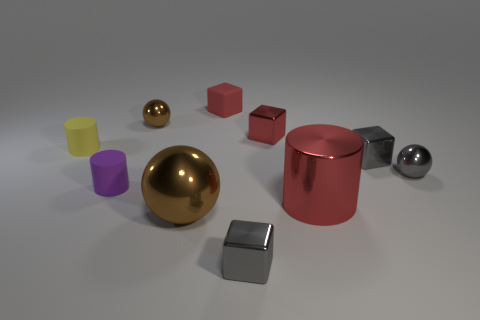What number of small objects are either gray metallic things or matte things?
Keep it short and to the point. 6. Is there anything else that is the same color as the metal cylinder?
Your response must be concise. Yes. There is a big brown object that is the same material as the small brown object; what shape is it?
Provide a short and direct response. Sphere. What size is the metallic thing that is in front of the large brown object?
Your response must be concise. Small. What shape is the large red thing?
Keep it short and to the point. Cylinder. There is a gray metallic thing that is to the left of the large cylinder; is its size the same as the brown shiny object that is behind the small yellow object?
Offer a terse response. Yes. How big is the gray metal cube that is on the right side of the gray metal cube that is in front of the cylinder that is on the right side of the small brown metal ball?
Your answer should be very brief. Small. What shape is the tiny gray thing in front of the small shiny ball on the right side of the red thing that is in front of the gray metal ball?
Ensure brevity in your answer.  Cube. What is the shape of the large object that is on the right side of the tiny rubber cube?
Offer a terse response. Cylinder. Does the large red object have the same material as the gray cube that is in front of the small purple matte cylinder?
Your answer should be compact. Yes. 